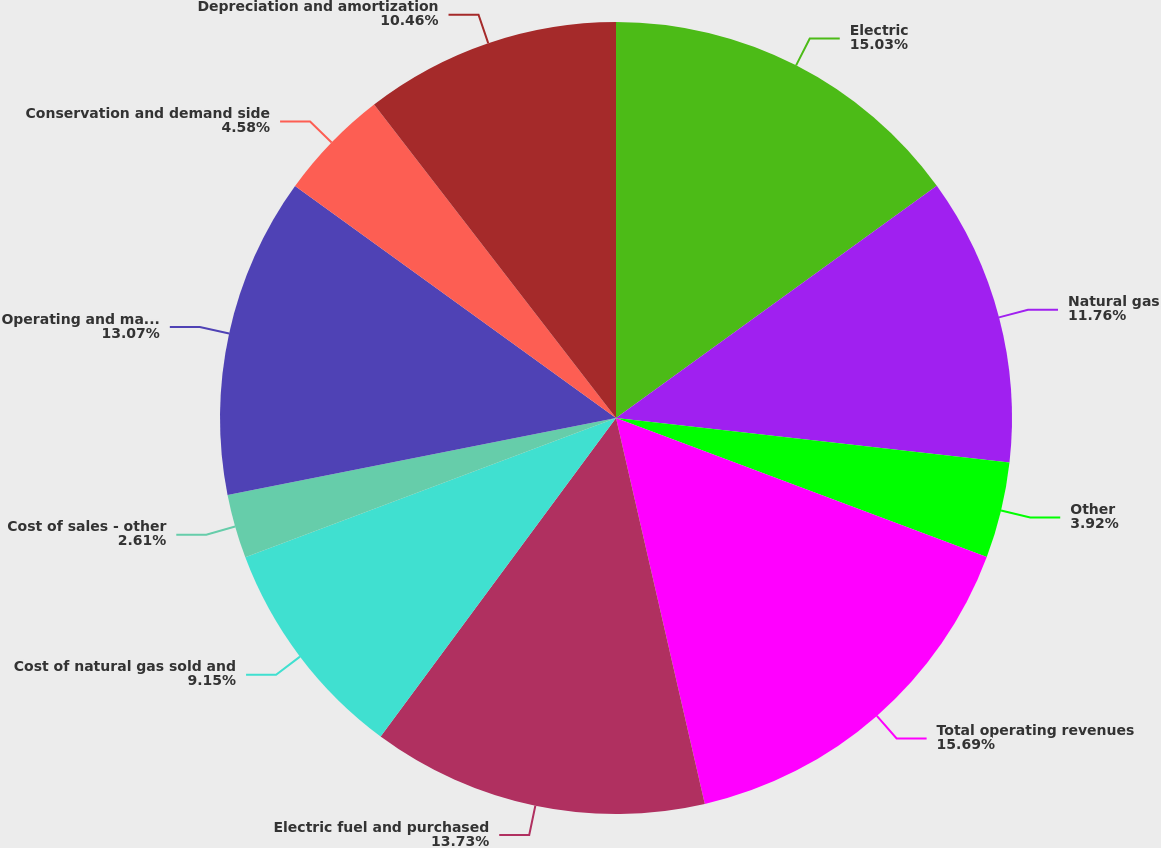Convert chart to OTSL. <chart><loc_0><loc_0><loc_500><loc_500><pie_chart><fcel>Electric<fcel>Natural gas<fcel>Other<fcel>Total operating revenues<fcel>Electric fuel and purchased<fcel>Cost of natural gas sold and<fcel>Cost of sales - other<fcel>Operating and maintenance<fcel>Conservation and demand side<fcel>Depreciation and amortization<nl><fcel>15.03%<fcel>11.76%<fcel>3.92%<fcel>15.69%<fcel>13.73%<fcel>9.15%<fcel>2.61%<fcel>13.07%<fcel>4.58%<fcel>10.46%<nl></chart> 